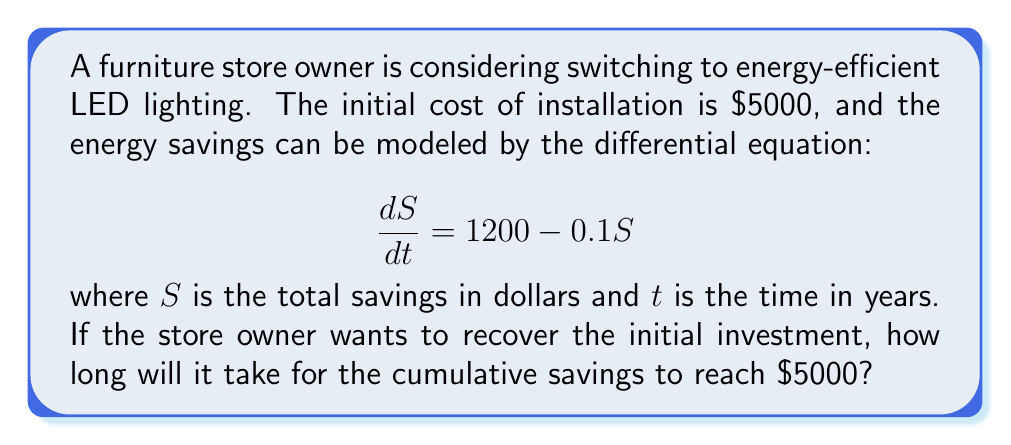Can you solve this math problem? To solve this problem, we need to follow these steps:

1. Solve the differential equation to find $S$ as a function of $t$.
2. Set $S(t) = 5000$ and solve for $t$.

Step 1: Solving the differential equation

The given differential equation is:

$$\frac{dS}{dt} = 1200 - 0.1S$$

This is a first-order linear differential equation. We can solve it using the integrating factor method.

The integrating factor is $e^{\int 0.1 dt} = e^{0.1t}$.

Multiplying both sides by the integrating factor:

$$e^{0.1t} \frac{dS}{dt} + 0.1e^{0.1t}S = 1200e^{0.1t}$$

The left side is now the derivative of $e^{0.1t}S$:

$$\frac{d}{dt}(e^{0.1t}S) = 1200e^{0.1t}$$

Integrating both sides:

$$e^{0.1t}S = 12000e^{0.1t} + C$$

Solving for $S$:

$$S(t) = 12000 + Ce^{-0.1t}$$

To find $C$, we use the initial condition $S(0) = 0$:

$$0 = 12000 + C$$
$$C = -12000$$

Therefore, the solution is:

$$S(t) = 12000(1 - e^{-0.1t})$$

Step 2: Finding the time to reach $5000 in savings

We need to solve:

$$5000 = 12000(1 - e^{-0.1t})$$

Dividing both sides by 12000:

$$\frac{5}{12} = 1 - e^{-0.1t}$$
$$e^{-0.1t} = \frac{7}{12}$$

Taking the natural logarithm of both sides:

$$-0.1t = \ln(\frac{7}{12})$$

Solving for $t$:

$$t = -10 \ln(\frac{7}{12}) \approx 5.38 \text{ years}$$
Answer: It will take approximately 5.38 years for the cumulative savings to reach $5000 and recover the initial investment. 